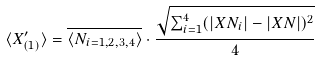Convert formula to latex. <formula><loc_0><loc_0><loc_500><loc_500>\langle X ^ { \prime } _ { ( 1 ) } \rangle = \overline { \langle N _ { i = 1 , 2 , 3 , 4 } \rangle } \cdot \frac { \sqrt { \sum _ { i = 1 } ^ { 4 } ( | X N _ { i } | - | X N | ) ^ { 2 } } } { 4 }</formula> 